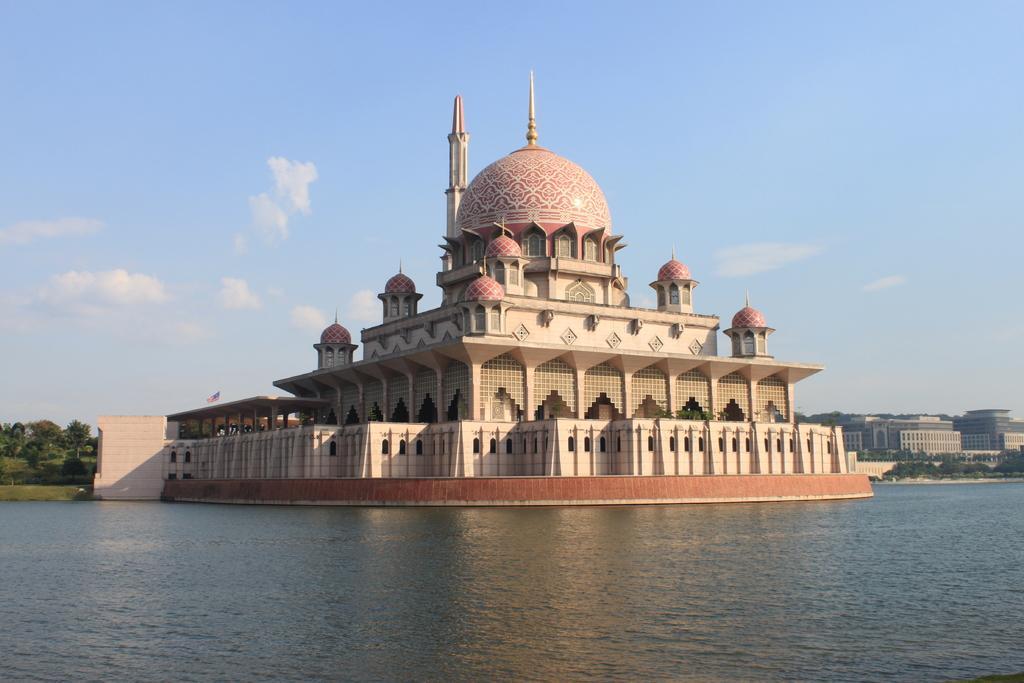Please provide a concise description of this image. In this picture we can see a mosque here, at the bottom there is water, on the left side we can see trees, on the right side there are some buildings, we can see the sky at the top of the picture. 